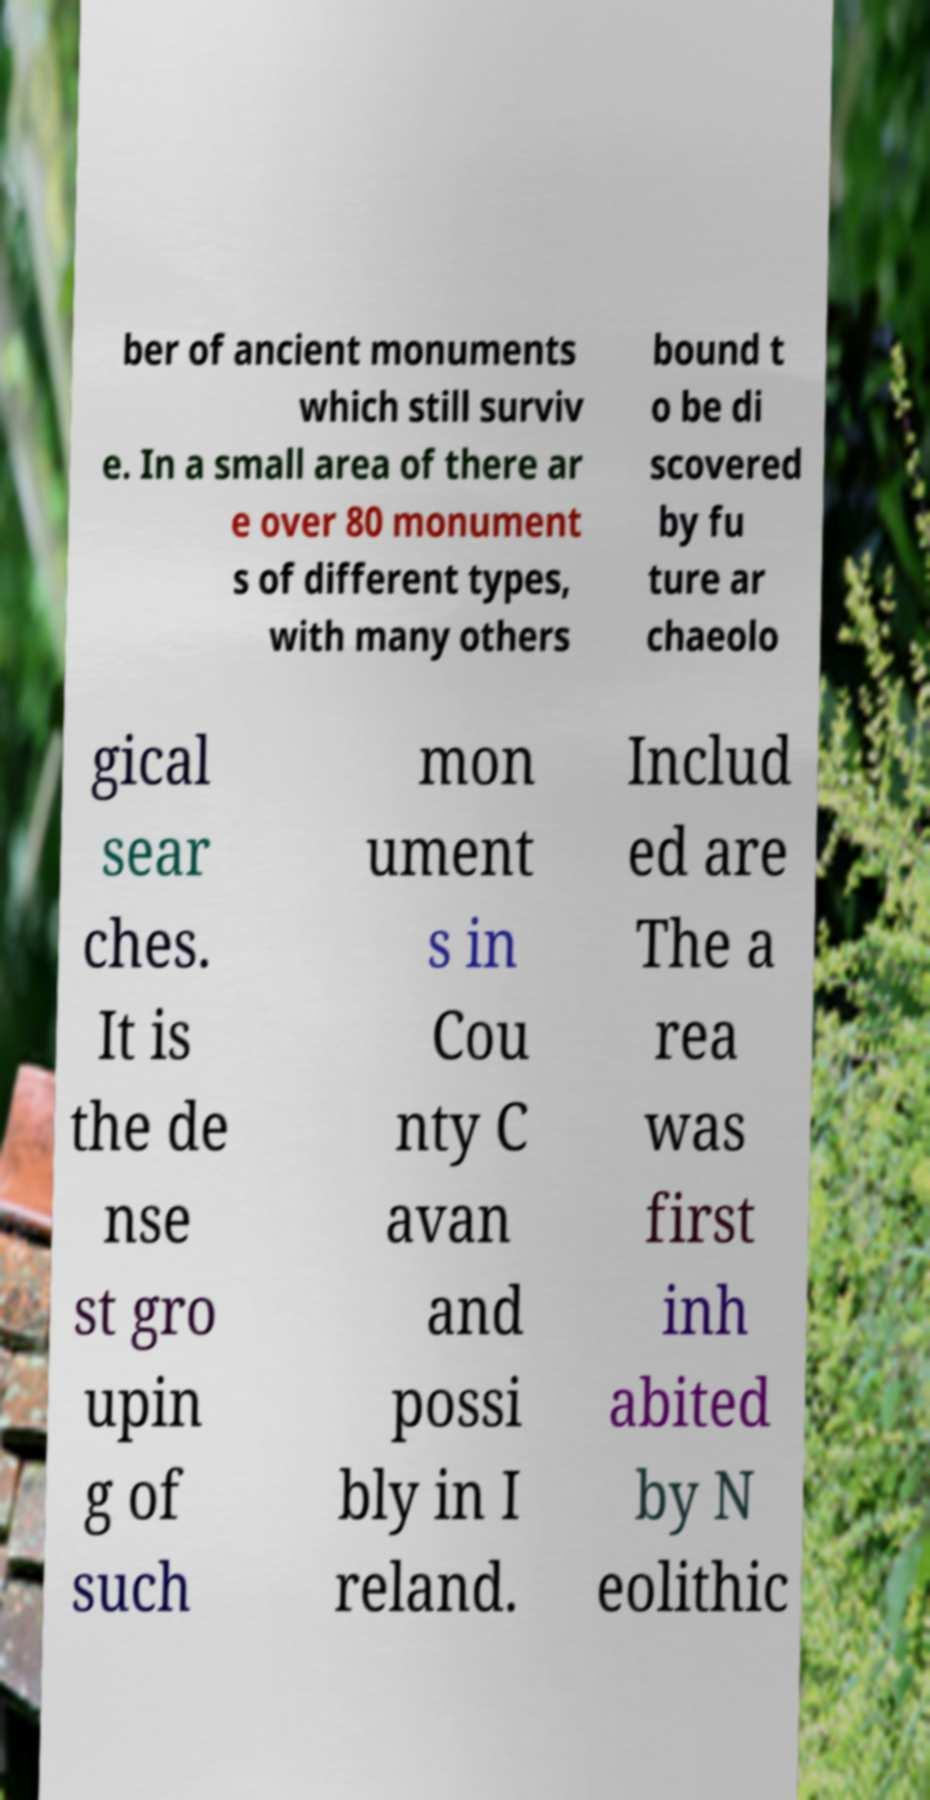I need the written content from this picture converted into text. Can you do that? ber of ancient monuments which still surviv e. In a small area of there ar e over 80 monument s of different types, with many others bound t o be di scovered by fu ture ar chaeolo gical sear ches. It is the de nse st gro upin g of such mon ument s in Cou nty C avan and possi bly in I reland. Includ ed are The a rea was first inh abited by N eolithic 